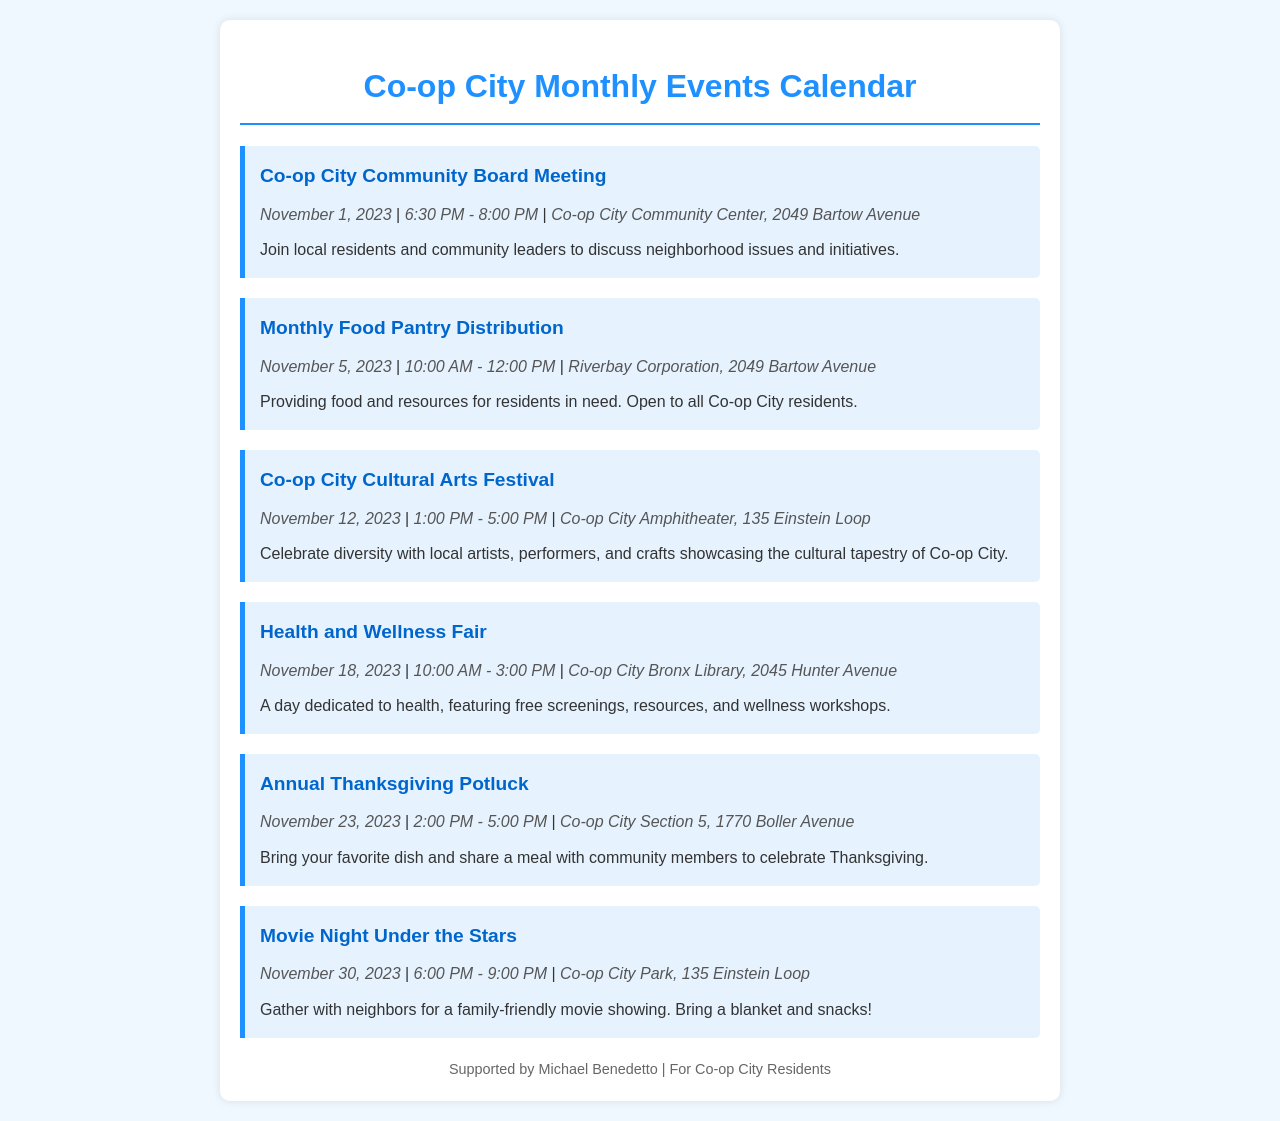What is the date of the Community Board Meeting? The date for the Community Board Meeting is explicitly mentioned in the event details section.
Answer: November 1, 2023 What time does the Food Pantry Distribution start? The starting time for the Food Pantry Distribution is listed in the event details section.
Answer: 10:00 AM Where is the Cultural Arts Festival being held? The location for the Cultural Arts Festival is specified along with the event details.
Answer: Co-op City Amphitheater, 135 Einstein Loop How long is the Health and Wellness Fair? The duration of the Health and Wellness Fair can be calculated from the start and end times provided in the event details.
Answer: 5 hours What is the title of the last event in the calendar? The title of the last event is clearly displayed in its respective section of the document.
Answer: Movie Night Under the Stars Which event takes place on Thanksgiving Day? The event that coincides with Thanksgiving Day is explicitly identified in the document among the events listed.
Answer: Annual Thanksgiving Potluck What is the theme of the Cultural Arts Festival? The theme for the Cultural Arts Festival can be understood from its description provided in the event section.
Answer: Celebrate diversity Who supports the community events mentioned in the calendar? The footer of the document identifies who supports the community events listed within the calendar.
Answer: Michael Benedetto 